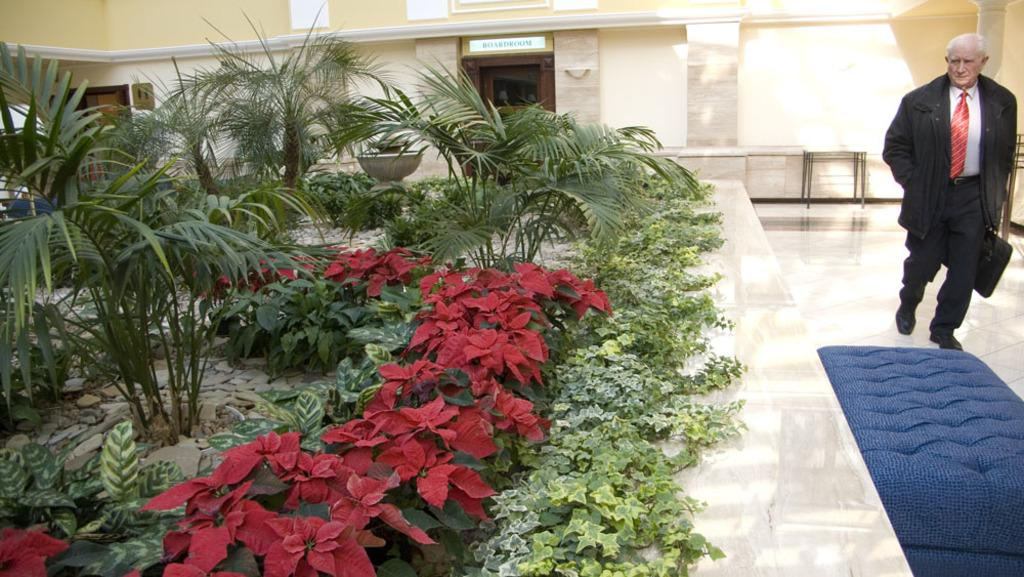What is the person in the image doing? The person is walking on the floor in the image. Where is the person located in the image? The person is on the right side of the image. What can be seen on the left side of the image? There are flower plants on the left side of the image. What is visible in the background of the image? There is a building in the background of the image. What type of property does the person own in the image? There is no information about the person owning any property in the image. How does the person stop walking in the image? The person does not stop walking in the image; they are continuously walking on the floor. 